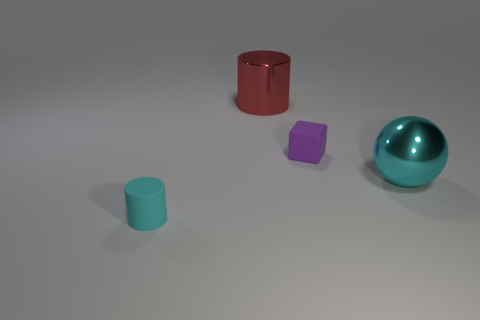How many rubber objects are either cubes or big red balls?
Your answer should be compact. 1. Is the number of big cyan things greater than the number of large purple balls?
Your response must be concise. Yes. What is the size of the rubber cylinder that is the same color as the sphere?
Ensure brevity in your answer.  Small. What is the shape of the tiny thing in front of the rubber thing behind the metallic sphere?
Offer a very short reply. Cylinder. There is a rubber object behind the cyan ball in front of the small matte block; are there any cyan matte things that are on the right side of it?
Offer a terse response. No. What is the color of the thing that is the same size as the cyan sphere?
Your response must be concise. Red. There is a object that is both on the left side of the purple object and in front of the red shiny cylinder; what is its shape?
Provide a succinct answer. Cylinder. There is a matte object that is behind the metal object to the right of the rubber cube; what is its size?
Give a very brief answer. Small. What number of tiny rubber cylinders are the same color as the large sphere?
Your answer should be very brief. 1. What number of other objects are the same size as the red metal thing?
Your answer should be very brief. 1. 